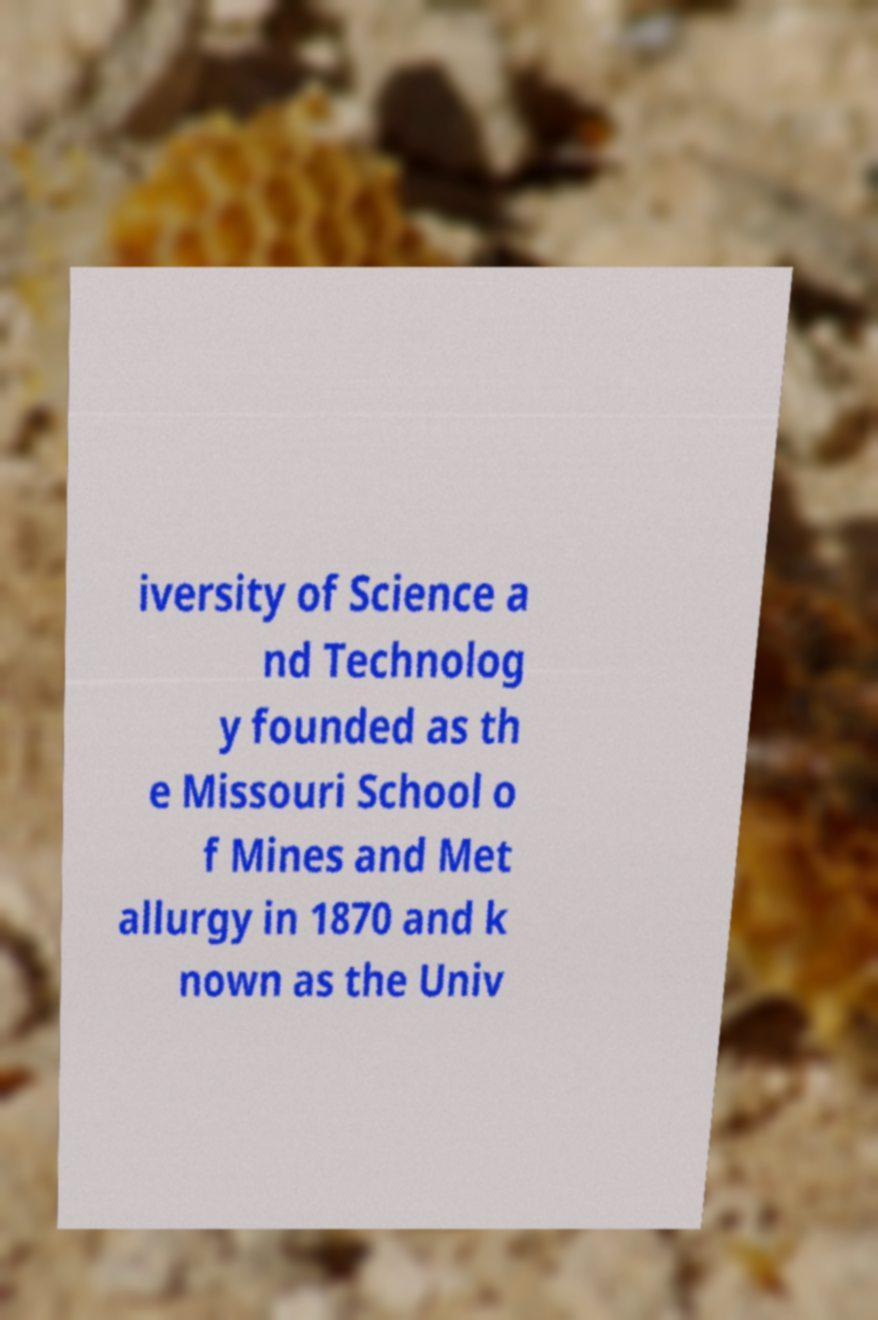For documentation purposes, I need the text within this image transcribed. Could you provide that? iversity of Science a nd Technolog y founded as th e Missouri School o f Mines and Met allurgy in 1870 and k nown as the Univ 